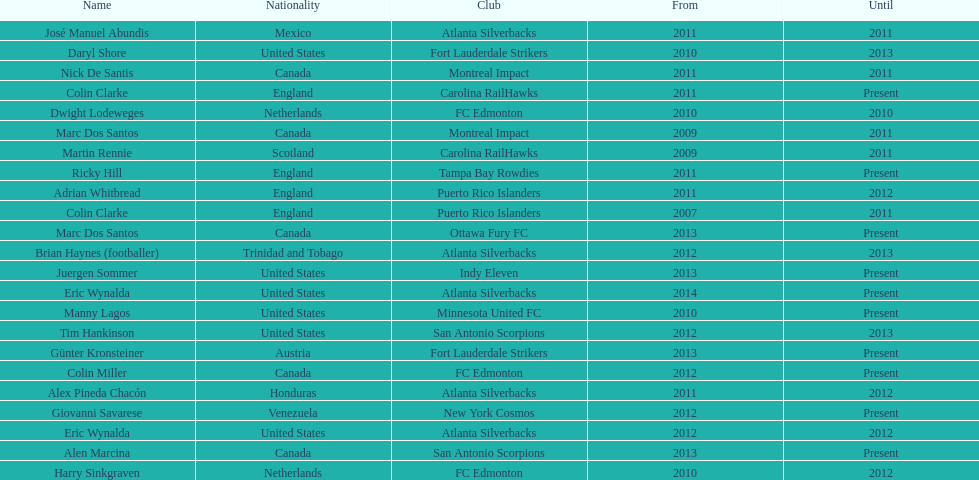How many total coaches on the list are from canada? 5. 